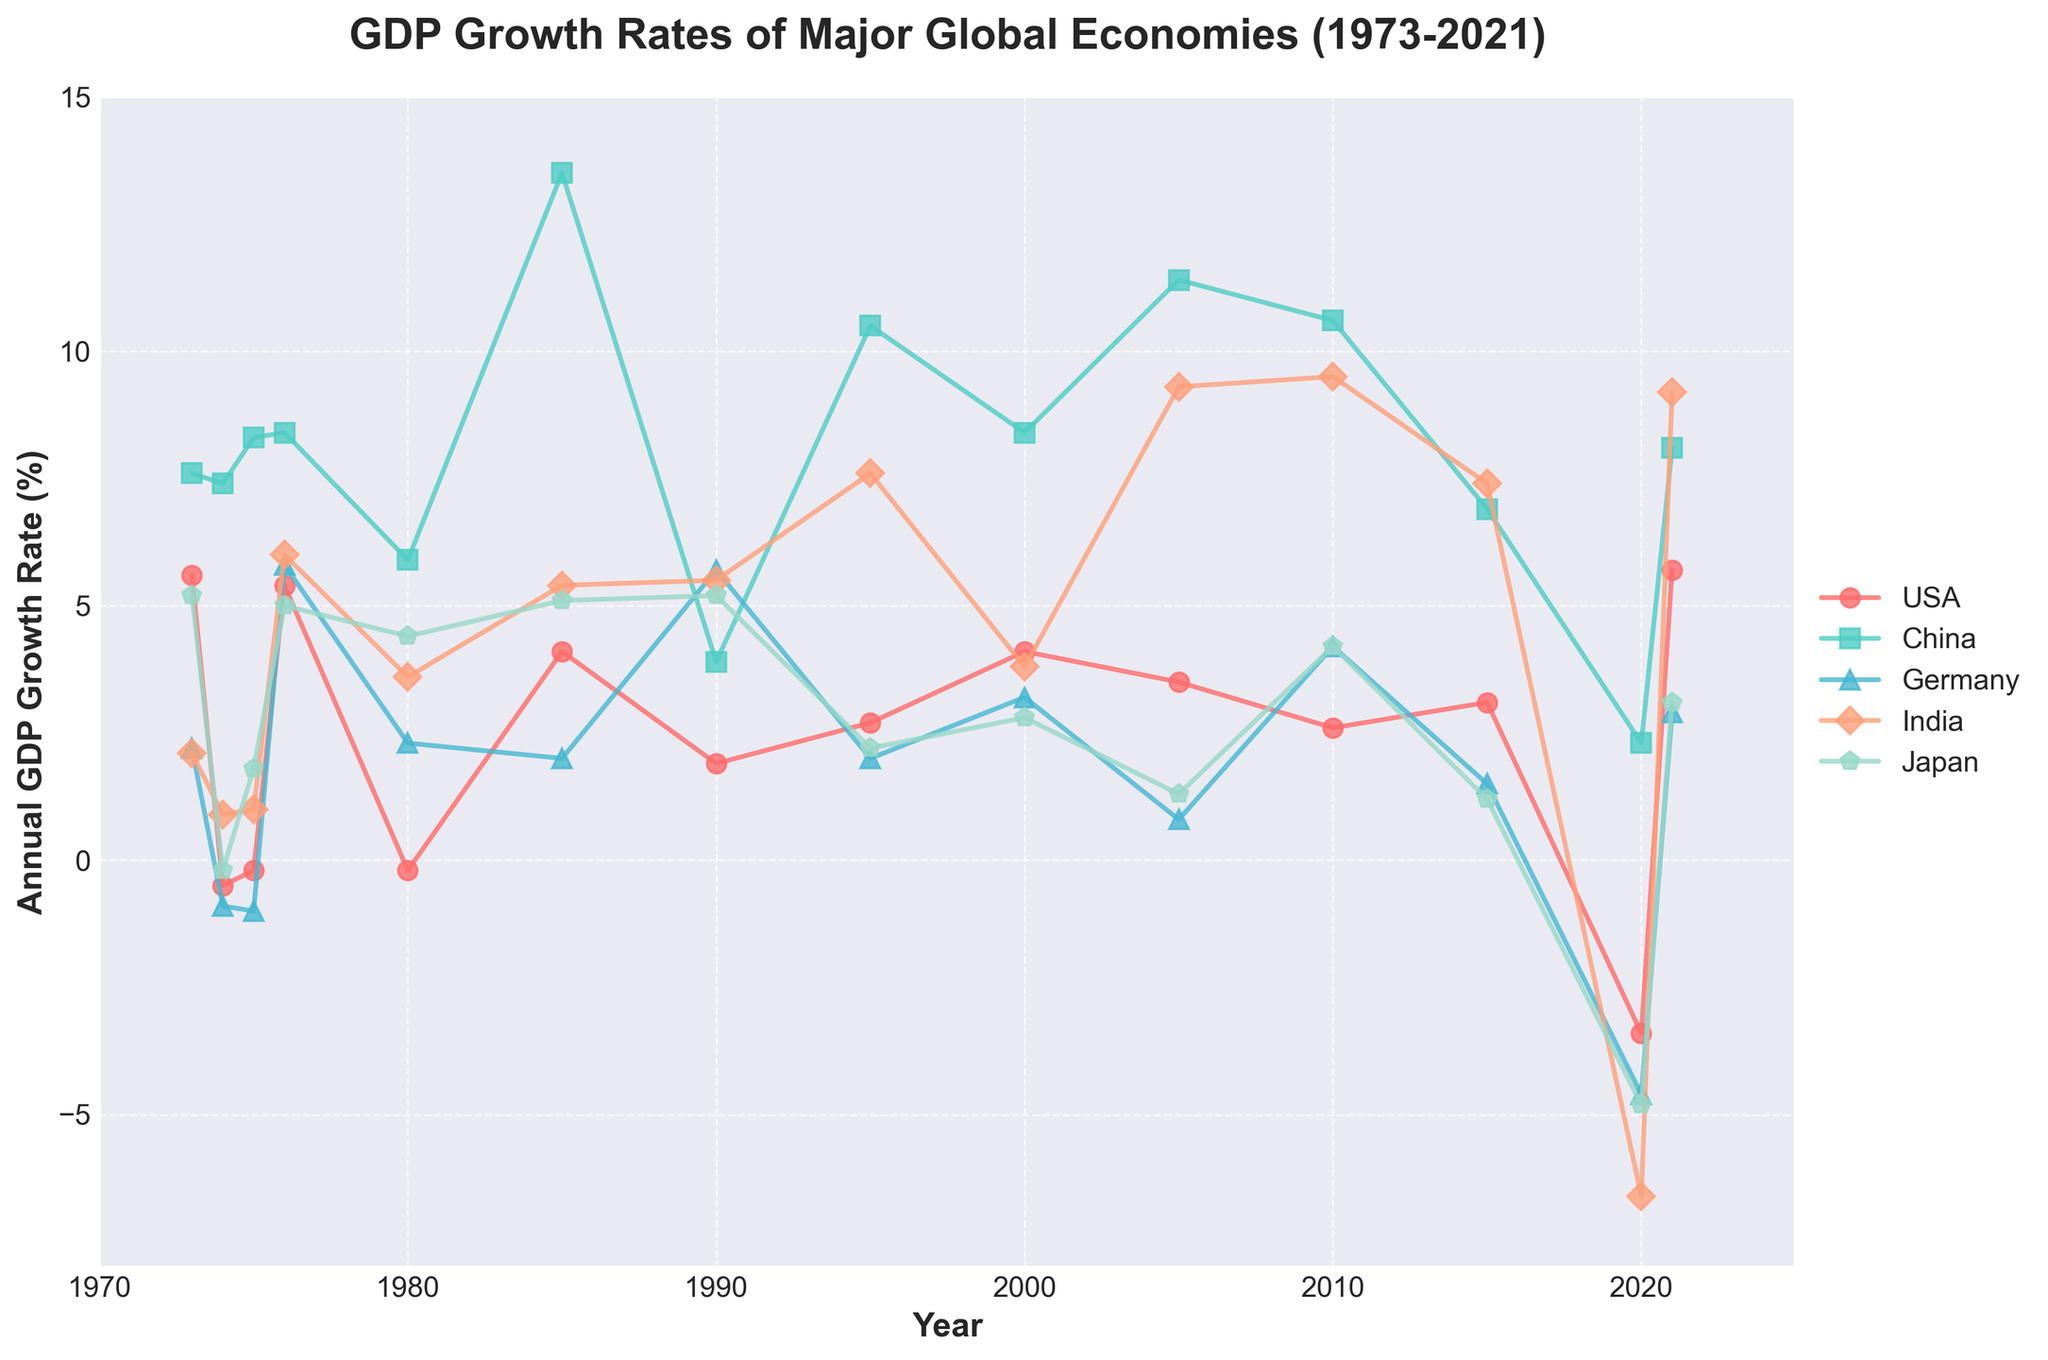What's the title of the figure? The title is displayed at the top of the figure in large, bold font. It provides a summary of the data and the time period covered.
Answer: GDP Growth Rates of Major Global Economies (1973-2021) Which country had the highest GDP growth rate in 2021? By examining the GDP growth rates for each country in the year 2021, we can identify the country with the largest value.
Answer: India What was the GDP growth rate of Japan in 1974? Locate the data point for Japan in 1974 on the figure to find the value.
Answer: -0.2% Which country experienced negative GDP growth in 2020? Observe the data points for 2020 and identify the countries that have data points below zero.
Answer: USA, Germany, India, Japan Between the years 1975 and 1976, which country showed the greatest increase in GDP growth rate? Calculate the difference in GDP growth rates between 1975 and 1976 for each country, and identify which country had the largest positive change.
Answer: Germany (increase of 6.8%) How many countries have their GDP growth rate drop below 0 during the timeframe displayed? Count the instances where the data points for each country fall below the x-axis (0% growth).
Answer: 4 (USA, Germany, India, Japan) What's the average GDP growth rate of Germany from 2000 to 2010 inclusive? Sum the GDP growth rates of Germany for the years 2000, 2005, and 2010, then divide by the number of data points.
Answer: (3.2 + 0.8 + 4.2)/3 = 2.73% Which country had the most consistent GDP growth rate over the 50-year period? Consistency can be observed by finding the country with the least fluctuations in growth rates.
Answer: China Was there any year when all five countries had positive GDP growth rates? Examine the data for all five countries year by year and identify if there is any year where all values are above zero.
Answer: 1990 What is the trend in GDP growth rate for China from 2015 to 2021? Observe the data points for China from 2015 to 2021 to determine if the trend is increasing, decreasing, or stable.
Answer: Increasing 